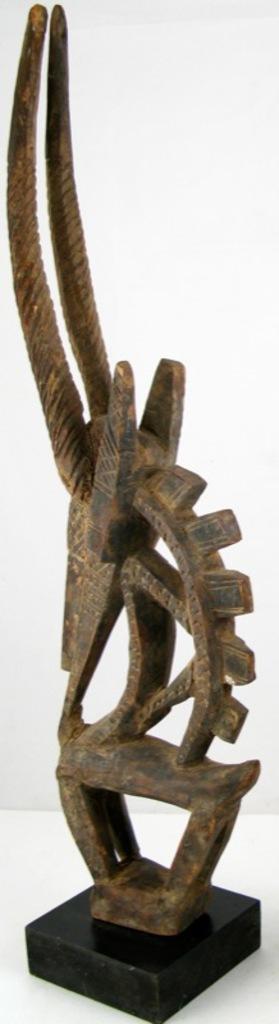Describe this image in one or two sentences. In this image we can see an object which is made up of metal. In the background of the image there is a white background. At the bottom of the image there is a white surface. 